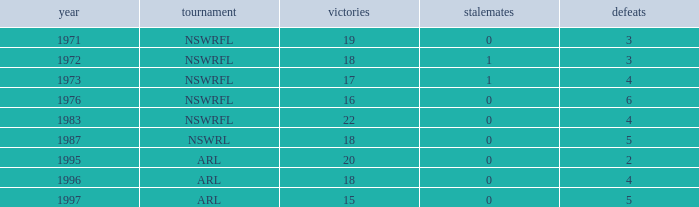What sum of Losses has Year greater than 1972, and Competition of nswrfl, and Draws 0, and Wins 16? 6.0. 